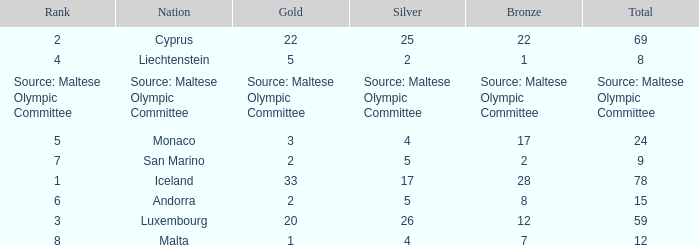What rank is the nation that has a bronze of source: Maltese Olympic Committee? Source: Maltese Olympic Committee. 